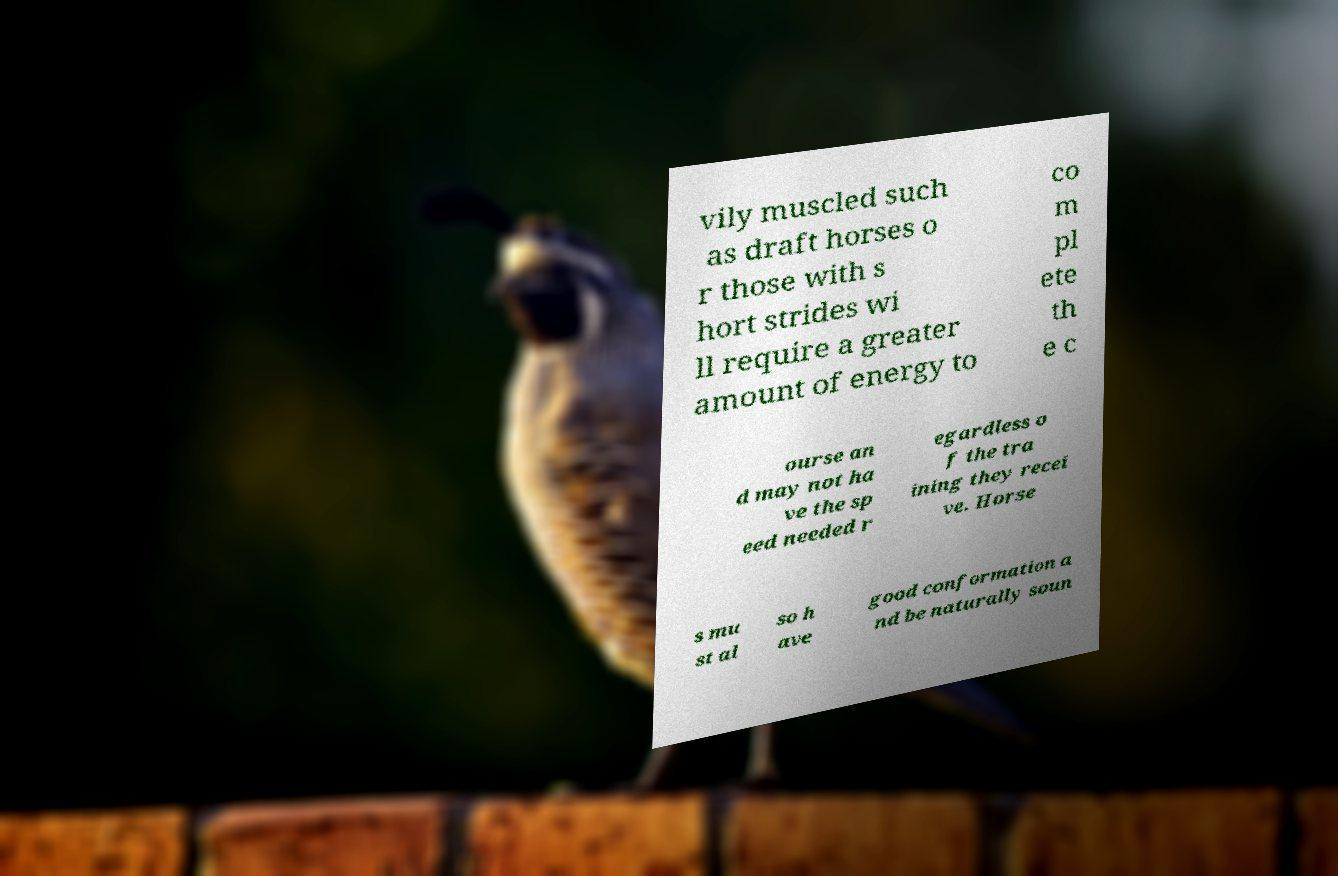Could you extract and type out the text from this image? vily muscled such as draft horses o r those with s hort strides wi ll require a greater amount of energy to co m pl ete th e c ourse an d may not ha ve the sp eed needed r egardless o f the tra ining they recei ve. Horse s mu st al so h ave good conformation a nd be naturally soun 